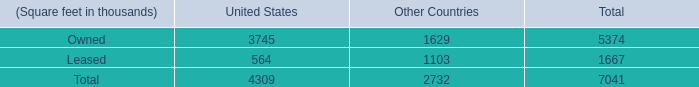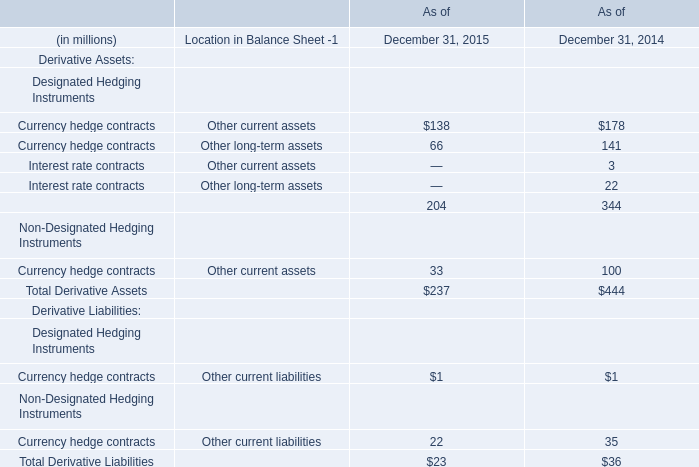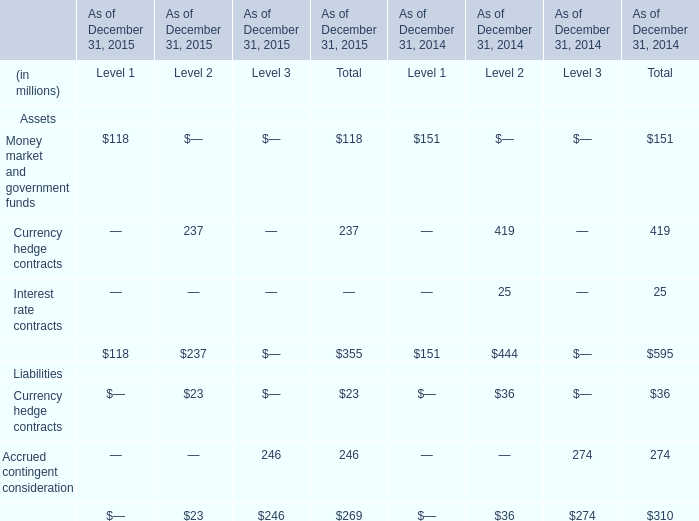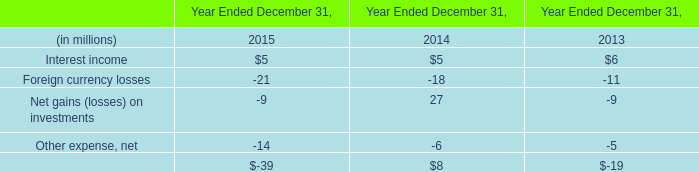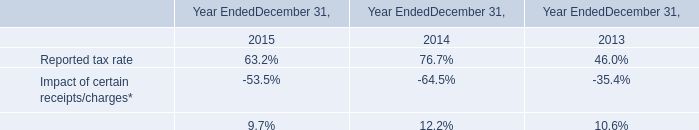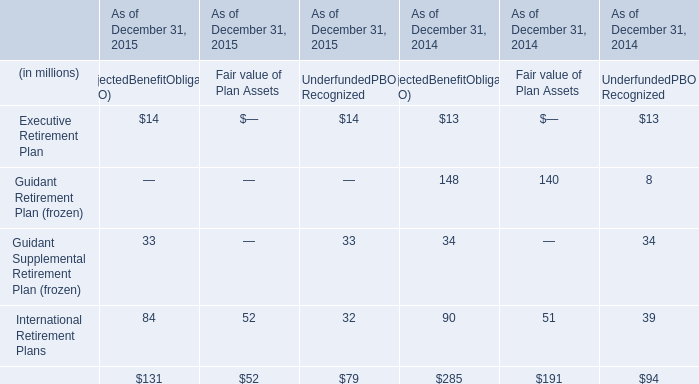What will Assets in Total reach in 2016 if it continues to grow at its current rate? (in millions) 
Computations: ((1 + ((355 - 595) / 595)) * 355)
Answer: 211.80672. 